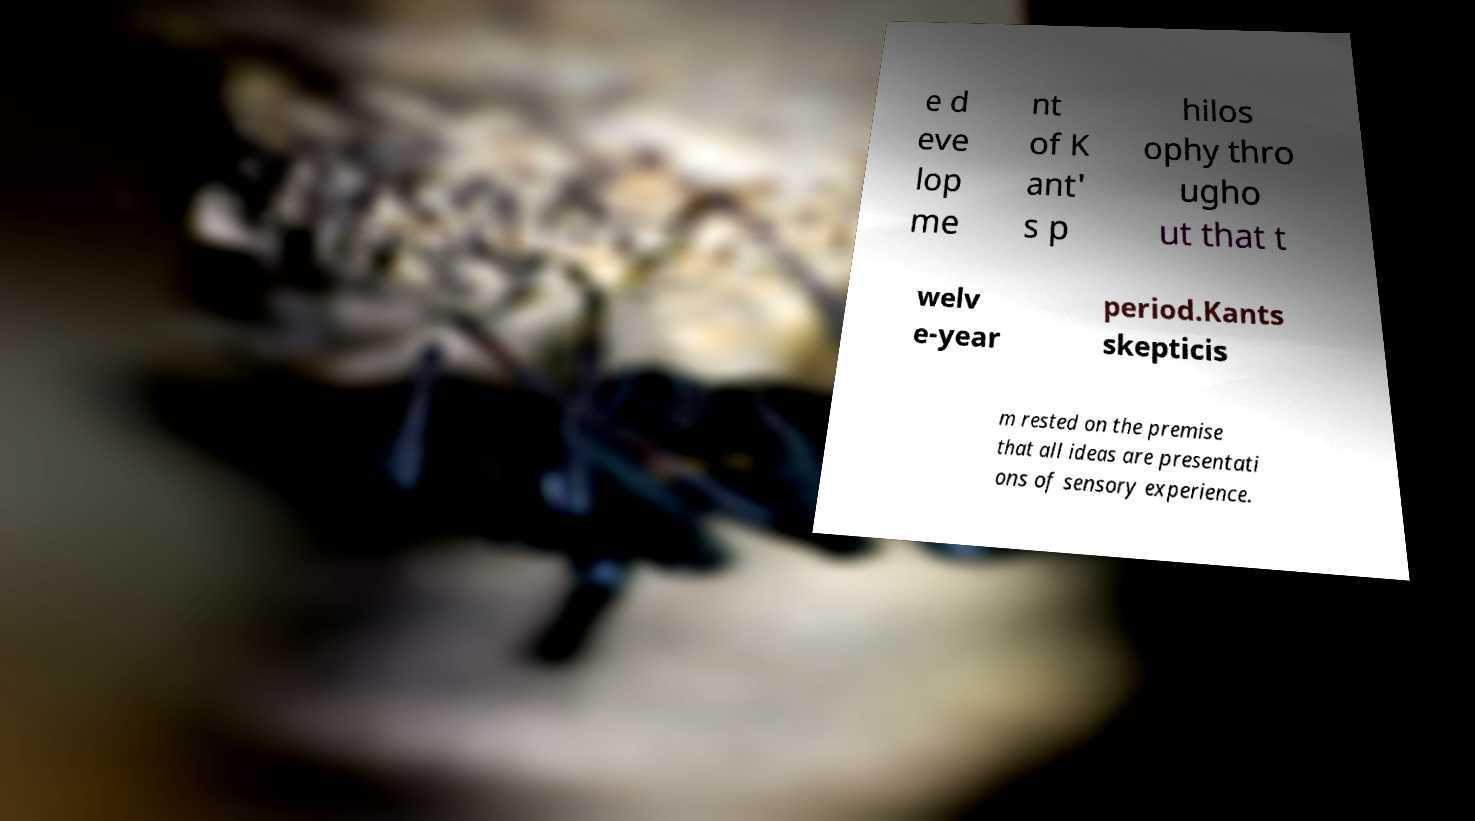Please identify and transcribe the text found in this image. e d eve lop me nt of K ant' s p hilos ophy thro ugho ut that t welv e-year period.Kants skepticis m rested on the premise that all ideas are presentati ons of sensory experience. 